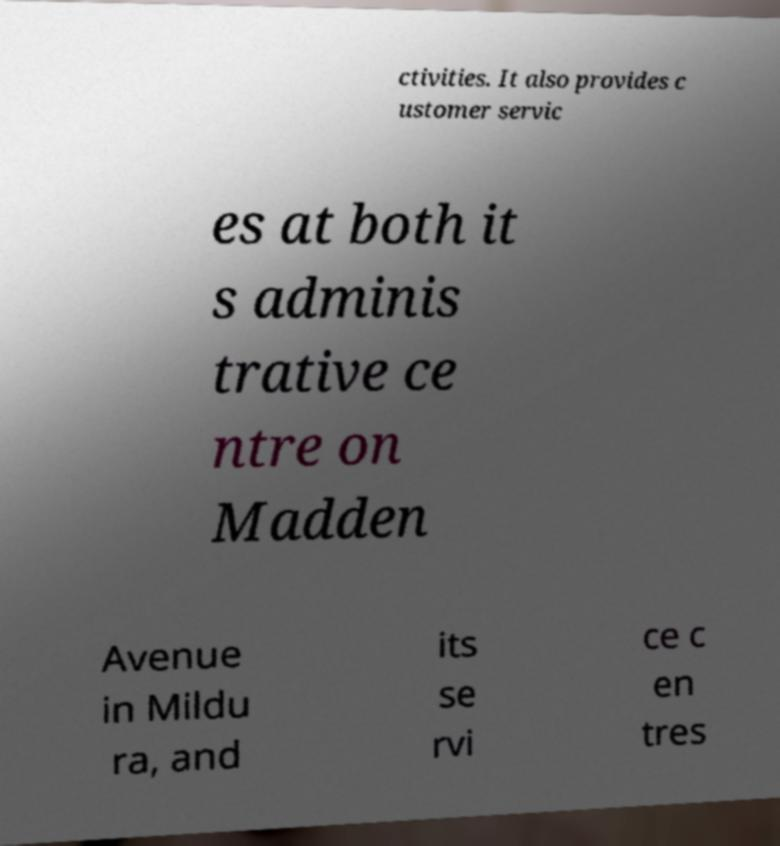For documentation purposes, I need the text within this image transcribed. Could you provide that? ctivities. It also provides c ustomer servic es at both it s adminis trative ce ntre on Madden Avenue in Mildu ra, and its se rvi ce c en tres 